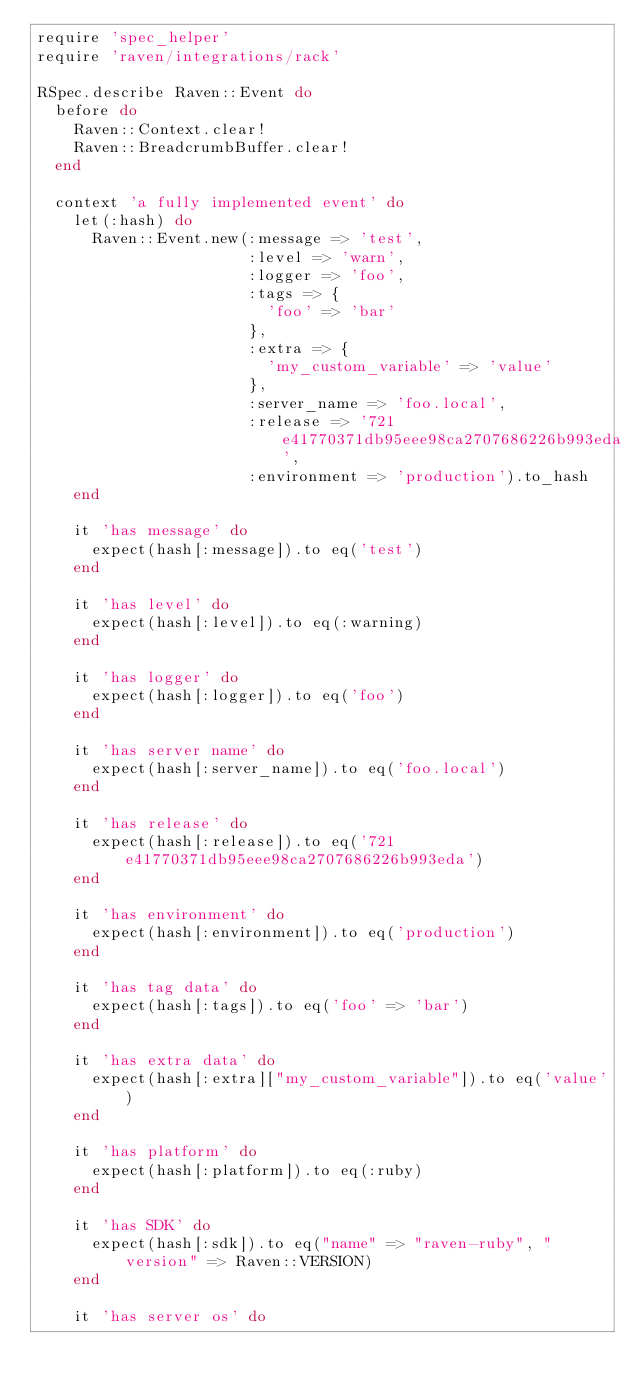Convert code to text. <code><loc_0><loc_0><loc_500><loc_500><_Ruby_>require 'spec_helper'
require 'raven/integrations/rack'

RSpec.describe Raven::Event do
  before do
    Raven::Context.clear!
    Raven::BreadcrumbBuffer.clear!
  end

  context 'a fully implemented event' do
    let(:hash) do
      Raven::Event.new(:message => 'test',
                       :level => 'warn',
                       :logger => 'foo',
                       :tags => {
                         'foo' => 'bar'
                       },
                       :extra => {
                         'my_custom_variable' => 'value'
                       },
                       :server_name => 'foo.local',
                       :release => '721e41770371db95eee98ca2707686226b993eda',
                       :environment => 'production').to_hash
    end

    it 'has message' do
      expect(hash[:message]).to eq('test')
    end

    it 'has level' do
      expect(hash[:level]).to eq(:warning)
    end

    it 'has logger' do
      expect(hash[:logger]).to eq('foo')
    end

    it 'has server name' do
      expect(hash[:server_name]).to eq('foo.local')
    end

    it 'has release' do
      expect(hash[:release]).to eq('721e41770371db95eee98ca2707686226b993eda')
    end

    it 'has environment' do
      expect(hash[:environment]).to eq('production')
    end

    it 'has tag data' do
      expect(hash[:tags]).to eq('foo' => 'bar')
    end

    it 'has extra data' do
      expect(hash[:extra]["my_custom_variable"]).to eq('value')
    end

    it 'has platform' do
      expect(hash[:platform]).to eq(:ruby)
    end

    it 'has SDK' do
      expect(hash[:sdk]).to eq("name" => "raven-ruby", "version" => Raven::VERSION)
    end

    it 'has server os' do</code> 